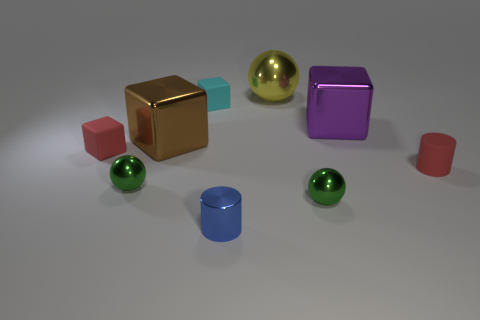Subtract all green metal balls. How many balls are left? 1 Subtract 2 cylinders. How many cylinders are left? 0 Add 1 small yellow objects. How many objects exist? 10 Subtract all red cylinders. How many cylinders are left? 1 Add 2 red matte blocks. How many red matte blocks are left? 3 Add 6 purple metallic cubes. How many purple metallic cubes exist? 7 Subtract 0 cyan balls. How many objects are left? 9 Subtract all cylinders. How many objects are left? 7 Subtract all red blocks. Subtract all cyan cylinders. How many blocks are left? 3 Subtract all green spheres. How many green cylinders are left? 0 